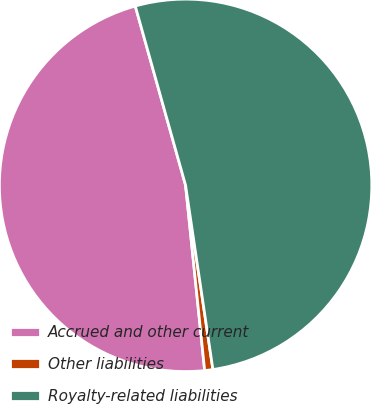Convert chart to OTSL. <chart><loc_0><loc_0><loc_500><loc_500><pie_chart><fcel>Accrued and other current<fcel>Other liabilities<fcel>Royalty-related liabilities<nl><fcel>47.28%<fcel>0.71%<fcel>52.01%<nl></chart> 